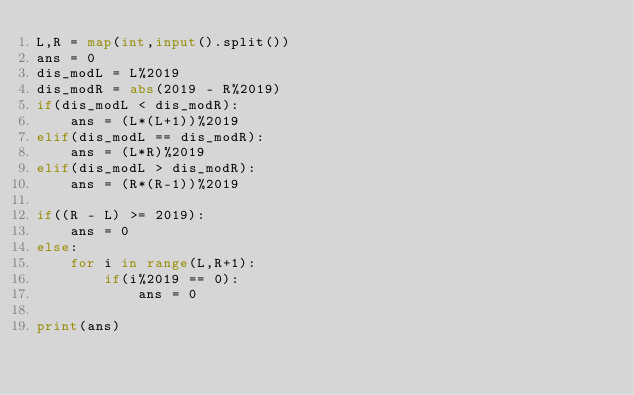<code> <loc_0><loc_0><loc_500><loc_500><_Python_>L,R = map(int,input().split())
ans = 0
dis_modL = L%2019
dis_modR = abs(2019 - R%2019)
if(dis_modL < dis_modR):
    ans = (L*(L+1))%2019
elif(dis_modL == dis_modR):
    ans = (L*R)%2019
elif(dis_modL > dis_modR):
    ans = (R*(R-1))%2019

if((R - L) >= 2019):
    ans = 0
else:
    for i in range(L,R+1):
        if(i%2019 == 0):
            ans = 0
        
print(ans)</code> 